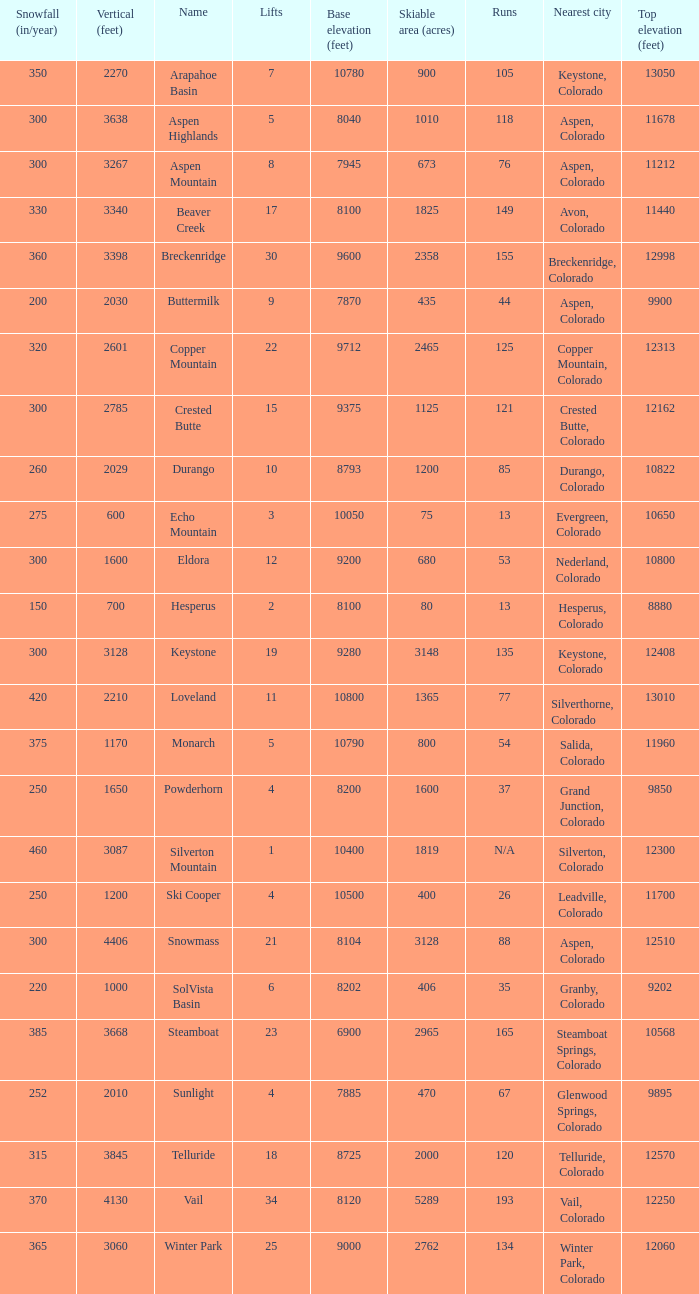Parse the full table. {'header': ['Snowfall (in/year)', 'Vertical (feet)', 'Name', 'Lifts', 'Base elevation (feet)', 'Skiable area (acres)', 'Runs', 'Nearest city', 'Top elevation (feet)'], 'rows': [['350', '2270', 'Arapahoe Basin', '7', '10780', '900', '105', 'Keystone, Colorado', '13050'], ['300', '3638', 'Aspen Highlands', '5', '8040', '1010', '118', 'Aspen, Colorado', '11678'], ['300', '3267', 'Aspen Mountain', '8', '7945', '673', '76', 'Aspen, Colorado', '11212'], ['330', '3340', 'Beaver Creek', '17', '8100', '1825', '149', 'Avon, Colorado', '11440'], ['360', '3398', 'Breckenridge', '30', '9600', '2358', '155', 'Breckenridge, Colorado', '12998'], ['200', '2030', 'Buttermilk', '9', '7870', '435', '44', 'Aspen, Colorado', '9900'], ['320', '2601', 'Copper Mountain', '22', '9712', '2465', '125', 'Copper Mountain, Colorado', '12313'], ['300', '2785', 'Crested Butte', '15', '9375', '1125', '121', 'Crested Butte, Colorado', '12162'], ['260', '2029', 'Durango', '10', '8793', '1200', '85', 'Durango, Colorado', '10822'], ['275', '600', 'Echo Mountain', '3', '10050', '75', '13', 'Evergreen, Colorado', '10650'], ['300', '1600', 'Eldora', '12', '9200', '680', '53', 'Nederland, Colorado', '10800'], ['150', '700', 'Hesperus', '2', '8100', '80', '13', 'Hesperus, Colorado', '8880'], ['300', '3128', 'Keystone', '19', '9280', '3148', '135', 'Keystone, Colorado', '12408'], ['420', '2210', 'Loveland', '11', '10800', '1365', '77', 'Silverthorne, Colorado', '13010'], ['375', '1170', 'Monarch', '5', '10790', '800', '54', 'Salida, Colorado', '11960'], ['250', '1650', 'Powderhorn', '4', '8200', '1600', '37', 'Grand Junction, Colorado', '9850'], ['460', '3087', 'Silverton Mountain', '1', '10400', '1819', 'N/A', 'Silverton, Colorado', '12300'], ['250', '1200', 'Ski Cooper', '4', '10500', '400', '26', 'Leadville, Colorado', '11700'], ['300', '4406', 'Snowmass', '21', '8104', '3128', '88', 'Aspen, Colorado', '12510'], ['220', '1000', 'SolVista Basin', '6', '8202', '406', '35', 'Granby, Colorado', '9202'], ['385', '3668', 'Steamboat', '23', '6900', '2965', '165', 'Steamboat Springs, Colorado', '10568'], ['252', '2010', 'Sunlight', '4', '7885', '470', '67', 'Glenwood Springs, Colorado', '9895'], ['315', '3845', 'Telluride', '18', '8725', '2000', '120', 'Telluride, Colorado', '12570'], ['370', '4130', 'Vail', '34', '8120', '5289', '193', 'Vail, Colorado', '12250'], ['365', '3060', 'Winter Park', '25', '9000', '2762', '134', 'Winter Park, Colorado', '12060']]} If there are 30 lifts, what is the name of the ski resort? Breckenridge. 